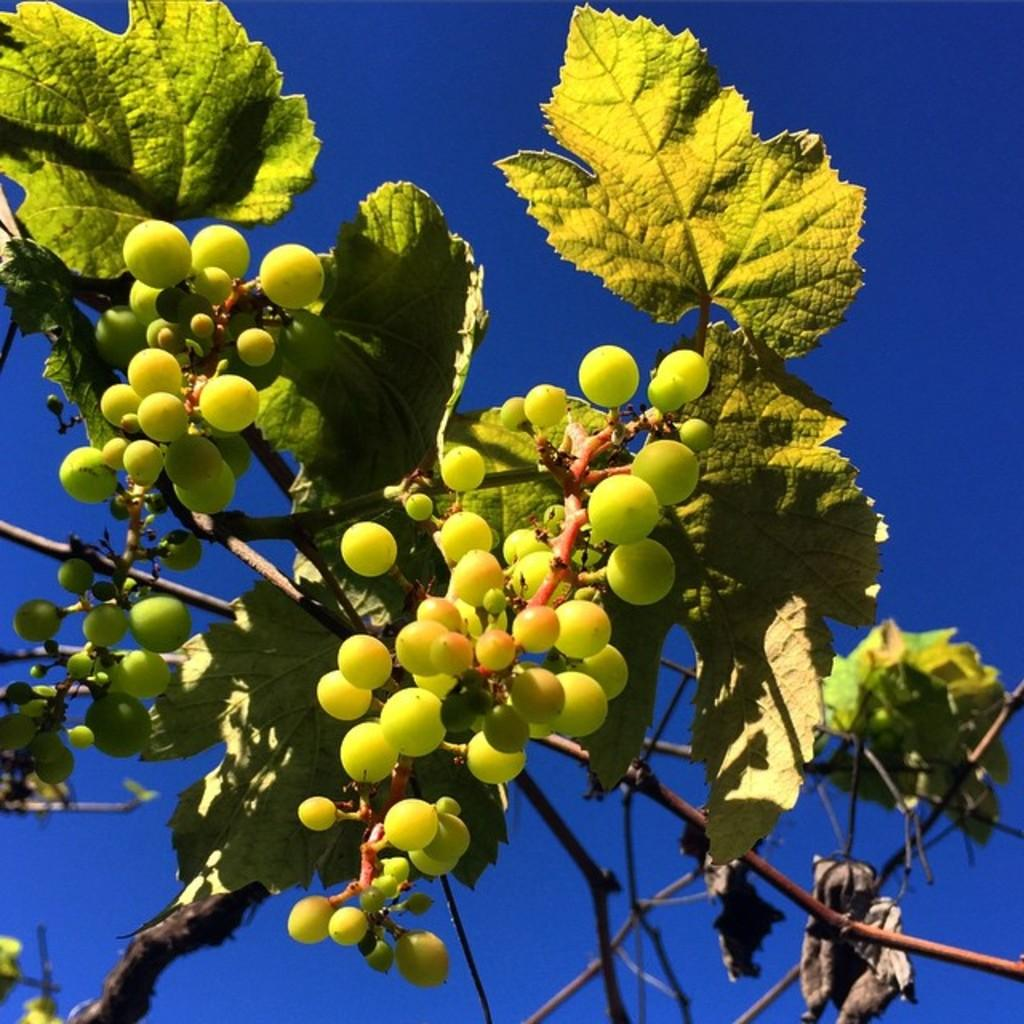What type of fruit is present in the image? There are green color grapes in the image. What additional features are present on the grapes? The grapes have leaves and stems. What can be seen in the background of the image? There is a sky visible in the background of the image. Can you see an ant carrying a face on a throne in the image? No, there is no ant, face, or throne present in the image. 